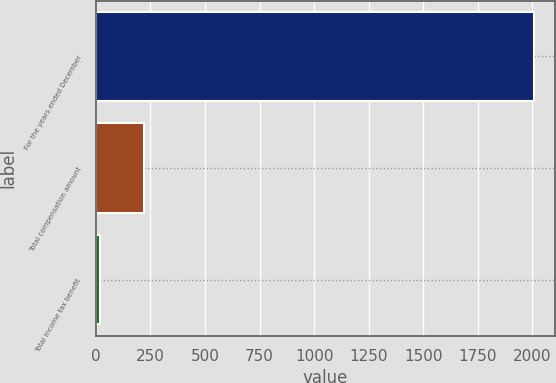Convert chart to OTSL. <chart><loc_0><loc_0><loc_500><loc_500><bar_chart><fcel>For the years ended December<fcel>Total compensation amount<fcel>Total income tax benefit<nl><fcel>2005<fcel>219.67<fcel>21.3<nl></chart> 